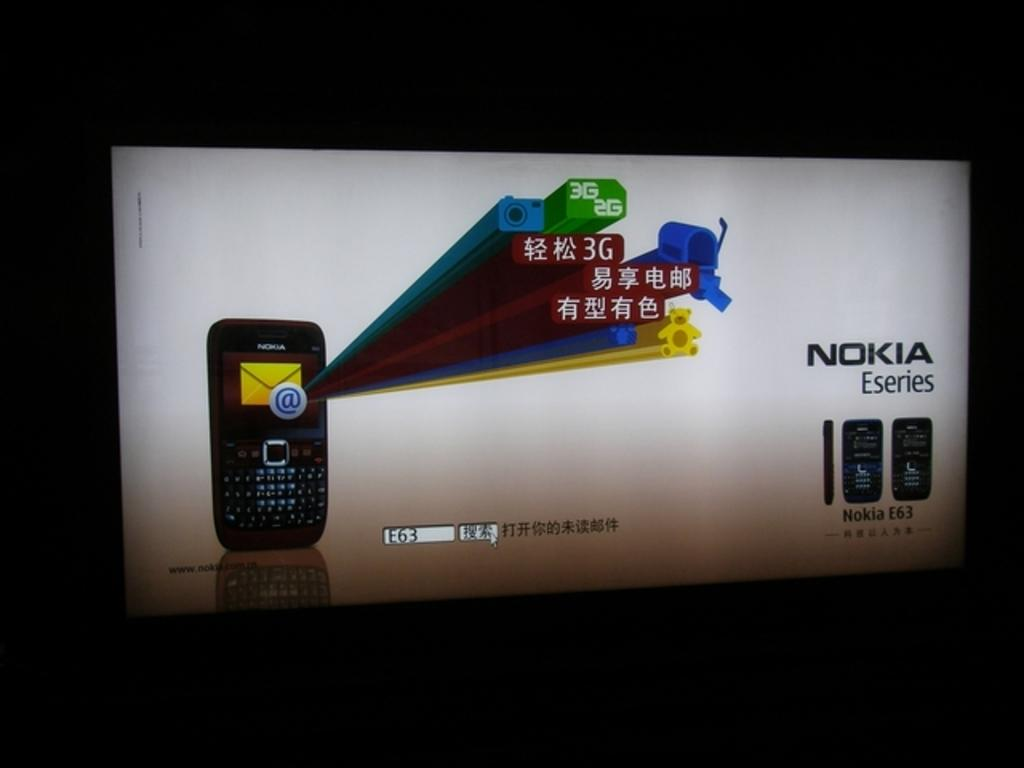Provide a one-sentence caption for the provided image. A Nokia Eseries electronic cell phone large advertisement. 